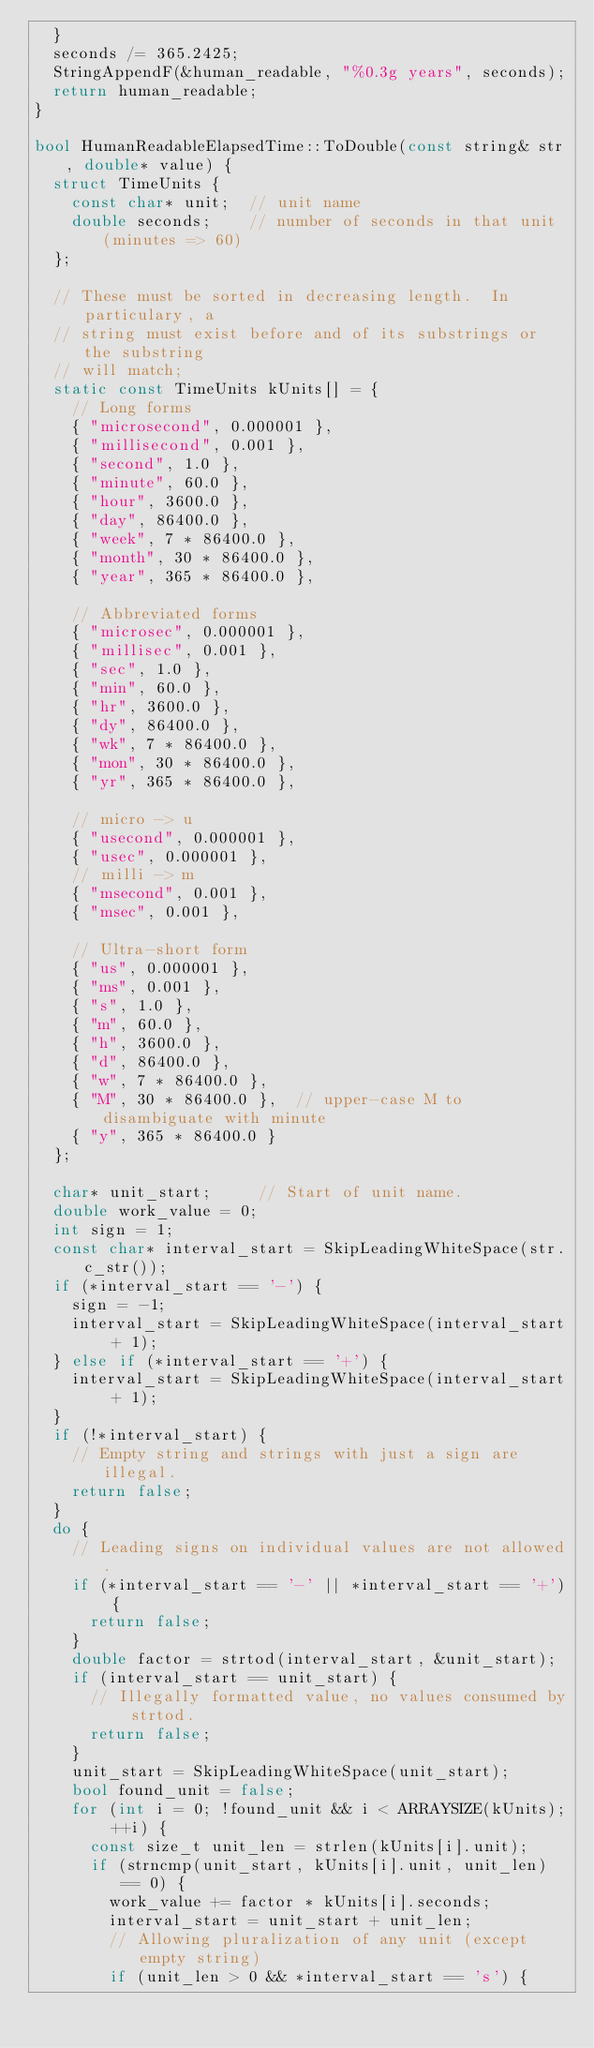<code> <loc_0><loc_0><loc_500><loc_500><_C++_>  }
  seconds /= 365.2425;
  StringAppendF(&human_readable, "%0.3g years", seconds);
  return human_readable;
}

bool HumanReadableElapsedTime::ToDouble(const string& str, double* value) {
  struct TimeUnits {
    const char* unit;  // unit name
    double seconds;    // number of seconds in that unit (minutes => 60)
  };

  // These must be sorted in decreasing length.  In particulary, a
  // string must exist before and of its substrings or the substring
  // will match;
  static const TimeUnits kUnits[] = {
    // Long forms
    { "microsecond", 0.000001 },
    { "millisecond", 0.001 },
    { "second", 1.0 },
    { "minute", 60.0 },
    { "hour", 3600.0 },
    { "day", 86400.0 },
    { "week", 7 * 86400.0 },
    { "month", 30 * 86400.0 },
    { "year", 365 * 86400.0 },

    // Abbreviated forms
    { "microsec", 0.000001 },
    { "millisec", 0.001 },
    { "sec", 1.0 },
    { "min", 60.0 },
    { "hr", 3600.0 },
    { "dy", 86400.0 },
    { "wk", 7 * 86400.0 },
    { "mon", 30 * 86400.0 },
    { "yr", 365 * 86400.0 },

    // micro -> u
    { "usecond", 0.000001 },
    { "usec", 0.000001 },
    // milli -> m
    { "msecond", 0.001 },
    { "msec", 0.001 },

    // Ultra-short form
    { "us", 0.000001 },
    { "ms", 0.001 },
    { "s", 1.0 },
    { "m", 60.0 },
    { "h", 3600.0 },
    { "d", 86400.0 },
    { "w", 7 * 86400.0 },
    { "M", 30 * 86400.0 },  // upper-case M to disambiguate with minute
    { "y", 365 * 86400.0 }
  };

  char* unit_start;     // Start of unit name.
  double work_value = 0;
  int sign = 1;
  const char* interval_start = SkipLeadingWhiteSpace(str.c_str());
  if (*interval_start == '-') {
    sign = -1;
    interval_start = SkipLeadingWhiteSpace(interval_start + 1);
  } else if (*interval_start == '+') {
    interval_start = SkipLeadingWhiteSpace(interval_start + 1);
  }
  if (!*interval_start) {
    // Empty string and strings with just a sign are illegal.
    return false;
  }
  do {
    // Leading signs on individual values are not allowed.
    if (*interval_start == '-' || *interval_start == '+') {
      return false;
    }
    double factor = strtod(interval_start, &unit_start);
    if (interval_start == unit_start) {
      // Illegally formatted value, no values consumed by strtod.
      return false;
    }
    unit_start = SkipLeadingWhiteSpace(unit_start);
    bool found_unit = false;
    for (int i = 0; !found_unit && i < ARRAYSIZE(kUnits); ++i) {
      const size_t unit_len = strlen(kUnits[i].unit);
      if (strncmp(unit_start, kUnits[i].unit, unit_len) == 0) {
        work_value += factor * kUnits[i].seconds;
        interval_start = unit_start + unit_len;
        // Allowing pluralization of any unit (except empty string)
        if (unit_len > 0 && *interval_start == 's') {</code> 